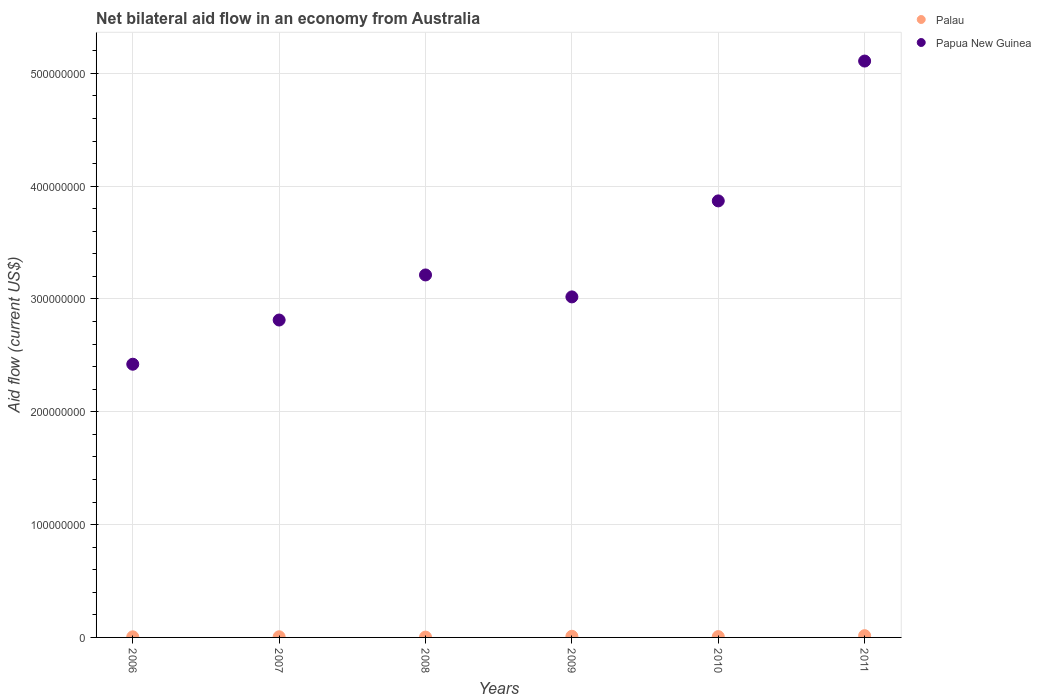What is the net bilateral aid flow in Palau in 2010?
Make the answer very short. 7.40e+05. Across all years, what is the maximum net bilateral aid flow in Palau?
Your answer should be compact. 1.57e+06. Across all years, what is the minimum net bilateral aid flow in Papua New Guinea?
Your response must be concise. 2.42e+08. In which year was the net bilateral aid flow in Palau maximum?
Keep it short and to the point. 2011. What is the total net bilateral aid flow in Palau in the graph?
Provide a succinct answer. 4.71e+06. What is the difference between the net bilateral aid flow in Papua New Guinea in 2007 and that in 2011?
Your answer should be compact. -2.30e+08. What is the difference between the net bilateral aid flow in Palau in 2011 and the net bilateral aid flow in Papua New Guinea in 2010?
Provide a succinct answer. -3.85e+08. What is the average net bilateral aid flow in Papua New Guinea per year?
Your answer should be very brief. 3.41e+08. In the year 2010, what is the difference between the net bilateral aid flow in Papua New Guinea and net bilateral aid flow in Palau?
Offer a terse response. 3.86e+08. In how many years, is the net bilateral aid flow in Palau greater than 260000000 US$?
Make the answer very short. 0. What is the ratio of the net bilateral aid flow in Papua New Guinea in 2007 to that in 2009?
Offer a very short reply. 0.93. What is the difference between the highest and the second highest net bilateral aid flow in Palau?
Offer a very short reply. 5.60e+05. What is the difference between the highest and the lowest net bilateral aid flow in Palau?
Give a very brief answer. 1.28e+06. In how many years, is the net bilateral aid flow in Papua New Guinea greater than the average net bilateral aid flow in Papua New Guinea taken over all years?
Offer a very short reply. 2. Does the net bilateral aid flow in Palau monotonically increase over the years?
Give a very brief answer. No. Is the net bilateral aid flow in Papua New Guinea strictly less than the net bilateral aid flow in Palau over the years?
Provide a short and direct response. No. What is the difference between two consecutive major ticks on the Y-axis?
Ensure brevity in your answer.  1.00e+08. How many legend labels are there?
Make the answer very short. 2. How are the legend labels stacked?
Provide a short and direct response. Vertical. What is the title of the graph?
Your answer should be compact. Net bilateral aid flow in an economy from Australia. Does "Low & middle income" appear as one of the legend labels in the graph?
Provide a succinct answer. No. What is the Aid flow (current US$) of Palau in 2006?
Make the answer very short. 5.20e+05. What is the Aid flow (current US$) of Papua New Guinea in 2006?
Provide a succinct answer. 2.42e+08. What is the Aid flow (current US$) in Palau in 2007?
Your answer should be compact. 5.80e+05. What is the Aid flow (current US$) in Papua New Guinea in 2007?
Provide a succinct answer. 2.81e+08. What is the Aid flow (current US$) in Palau in 2008?
Offer a very short reply. 2.90e+05. What is the Aid flow (current US$) of Papua New Guinea in 2008?
Ensure brevity in your answer.  3.21e+08. What is the Aid flow (current US$) in Palau in 2009?
Keep it short and to the point. 1.01e+06. What is the Aid flow (current US$) of Papua New Guinea in 2009?
Offer a terse response. 3.02e+08. What is the Aid flow (current US$) in Palau in 2010?
Ensure brevity in your answer.  7.40e+05. What is the Aid flow (current US$) in Papua New Guinea in 2010?
Provide a short and direct response. 3.87e+08. What is the Aid flow (current US$) of Palau in 2011?
Your answer should be compact. 1.57e+06. What is the Aid flow (current US$) in Papua New Guinea in 2011?
Make the answer very short. 5.11e+08. Across all years, what is the maximum Aid flow (current US$) of Palau?
Offer a very short reply. 1.57e+06. Across all years, what is the maximum Aid flow (current US$) of Papua New Guinea?
Give a very brief answer. 5.11e+08. Across all years, what is the minimum Aid flow (current US$) of Papua New Guinea?
Your answer should be compact. 2.42e+08. What is the total Aid flow (current US$) of Palau in the graph?
Your answer should be very brief. 4.71e+06. What is the total Aid flow (current US$) of Papua New Guinea in the graph?
Provide a short and direct response. 2.04e+09. What is the difference between the Aid flow (current US$) in Palau in 2006 and that in 2007?
Keep it short and to the point. -6.00e+04. What is the difference between the Aid flow (current US$) of Papua New Guinea in 2006 and that in 2007?
Offer a terse response. -3.92e+07. What is the difference between the Aid flow (current US$) in Palau in 2006 and that in 2008?
Your answer should be very brief. 2.30e+05. What is the difference between the Aid flow (current US$) in Papua New Guinea in 2006 and that in 2008?
Offer a terse response. -7.91e+07. What is the difference between the Aid flow (current US$) in Palau in 2006 and that in 2009?
Ensure brevity in your answer.  -4.90e+05. What is the difference between the Aid flow (current US$) of Papua New Guinea in 2006 and that in 2009?
Provide a succinct answer. -5.97e+07. What is the difference between the Aid flow (current US$) in Papua New Guinea in 2006 and that in 2010?
Provide a succinct answer. -1.45e+08. What is the difference between the Aid flow (current US$) in Palau in 2006 and that in 2011?
Keep it short and to the point. -1.05e+06. What is the difference between the Aid flow (current US$) of Papua New Guinea in 2006 and that in 2011?
Ensure brevity in your answer.  -2.69e+08. What is the difference between the Aid flow (current US$) of Papua New Guinea in 2007 and that in 2008?
Keep it short and to the point. -4.00e+07. What is the difference between the Aid flow (current US$) in Palau in 2007 and that in 2009?
Make the answer very short. -4.30e+05. What is the difference between the Aid flow (current US$) of Papua New Guinea in 2007 and that in 2009?
Provide a short and direct response. -2.05e+07. What is the difference between the Aid flow (current US$) in Papua New Guinea in 2007 and that in 2010?
Your response must be concise. -1.06e+08. What is the difference between the Aid flow (current US$) in Palau in 2007 and that in 2011?
Your answer should be very brief. -9.90e+05. What is the difference between the Aid flow (current US$) in Papua New Guinea in 2007 and that in 2011?
Provide a short and direct response. -2.30e+08. What is the difference between the Aid flow (current US$) of Palau in 2008 and that in 2009?
Offer a very short reply. -7.20e+05. What is the difference between the Aid flow (current US$) of Papua New Guinea in 2008 and that in 2009?
Provide a short and direct response. 1.94e+07. What is the difference between the Aid flow (current US$) in Palau in 2008 and that in 2010?
Provide a short and direct response. -4.50e+05. What is the difference between the Aid flow (current US$) in Papua New Guinea in 2008 and that in 2010?
Provide a succinct answer. -6.56e+07. What is the difference between the Aid flow (current US$) of Palau in 2008 and that in 2011?
Offer a very short reply. -1.28e+06. What is the difference between the Aid flow (current US$) of Papua New Guinea in 2008 and that in 2011?
Keep it short and to the point. -1.90e+08. What is the difference between the Aid flow (current US$) in Palau in 2009 and that in 2010?
Ensure brevity in your answer.  2.70e+05. What is the difference between the Aid flow (current US$) of Papua New Guinea in 2009 and that in 2010?
Give a very brief answer. -8.51e+07. What is the difference between the Aid flow (current US$) of Palau in 2009 and that in 2011?
Offer a very short reply. -5.60e+05. What is the difference between the Aid flow (current US$) in Papua New Guinea in 2009 and that in 2011?
Your answer should be very brief. -2.09e+08. What is the difference between the Aid flow (current US$) in Palau in 2010 and that in 2011?
Ensure brevity in your answer.  -8.30e+05. What is the difference between the Aid flow (current US$) in Papua New Guinea in 2010 and that in 2011?
Provide a short and direct response. -1.24e+08. What is the difference between the Aid flow (current US$) in Palau in 2006 and the Aid flow (current US$) in Papua New Guinea in 2007?
Your answer should be very brief. -2.81e+08. What is the difference between the Aid flow (current US$) of Palau in 2006 and the Aid flow (current US$) of Papua New Guinea in 2008?
Give a very brief answer. -3.21e+08. What is the difference between the Aid flow (current US$) in Palau in 2006 and the Aid flow (current US$) in Papua New Guinea in 2009?
Offer a terse response. -3.01e+08. What is the difference between the Aid flow (current US$) of Palau in 2006 and the Aid flow (current US$) of Papua New Guinea in 2010?
Your answer should be very brief. -3.86e+08. What is the difference between the Aid flow (current US$) of Palau in 2006 and the Aid flow (current US$) of Papua New Guinea in 2011?
Give a very brief answer. -5.10e+08. What is the difference between the Aid flow (current US$) in Palau in 2007 and the Aid flow (current US$) in Papua New Guinea in 2008?
Keep it short and to the point. -3.21e+08. What is the difference between the Aid flow (current US$) of Palau in 2007 and the Aid flow (current US$) of Papua New Guinea in 2009?
Provide a short and direct response. -3.01e+08. What is the difference between the Aid flow (current US$) of Palau in 2007 and the Aid flow (current US$) of Papua New Guinea in 2010?
Make the answer very short. -3.86e+08. What is the difference between the Aid flow (current US$) of Palau in 2007 and the Aid flow (current US$) of Papua New Guinea in 2011?
Provide a succinct answer. -5.10e+08. What is the difference between the Aid flow (current US$) in Palau in 2008 and the Aid flow (current US$) in Papua New Guinea in 2009?
Your answer should be very brief. -3.02e+08. What is the difference between the Aid flow (current US$) of Palau in 2008 and the Aid flow (current US$) of Papua New Guinea in 2010?
Provide a succinct answer. -3.87e+08. What is the difference between the Aid flow (current US$) in Palau in 2008 and the Aid flow (current US$) in Papua New Guinea in 2011?
Your answer should be very brief. -5.11e+08. What is the difference between the Aid flow (current US$) of Palau in 2009 and the Aid flow (current US$) of Papua New Guinea in 2010?
Your answer should be compact. -3.86e+08. What is the difference between the Aid flow (current US$) in Palau in 2009 and the Aid flow (current US$) in Papua New Guinea in 2011?
Give a very brief answer. -5.10e+08. What is the difference between the Aid flow (current US$) of Palau in 2010 and the Aid flow (current US$) of Papua New Guinea in 2011?
Your response must be concise. -5.10e+08. What is the average Aid flow (current US$) of Palau per year?
Offer a very short reply. 7.85e+05. What is the average Aid flow (current US$) of Papua New Guinea per year?
Your answer should be compact. 3.41e+08. In the year 2006, what is the difference between the Aid flow (current US$) in Palau and Aid flow (current US$) in Papua New Guinea?
Make the answer very short. -2.42e+08. In the year 2007, what is the difference between the Aid flow (current US$) in Palau and Aid flow (current US$) in Papua New Guinea?
Provide a succinct answer. -2.81e+08. In the year 2008, what is the difference between the Aid flow (current US$) in Palau and Aid flow (current US$) in Papua New Guinea?
Provide a short and direct response. -3.21e+08. In the year 2009, what is the difference between the Aid flow (current US$) of Palau and Aid flow (current US$) of Papua New Guinea?
Provide a succinct answer. -3.01e+08. In the year 2010, what is the difference between the Aid flow (current US$) in Palau and Aid flow (current US$) in Papua New Guinea?
Offer a terse response. -3.86e+08. In the year 2011, what is the difference between the Aid flow (current US$) of Palau and Aid flow (current US$) of Papua New Guinea?
Your answer should be compact. -5.09e+08. What is the ratio of the Aid flow (current US$) of Palau in 2006 to that in 2007?
Provide a succinct answer. 0.9. What is the ratio of the Aid flow (current US$) in Papua New Guinea in 2006 to that in 2007?
Keep it short and to the point. 0.86. What is the ratio of the Aid flow (current US$) of Palau in 2006 to that in 2008?
Make the answer very short. 1.79. What is the ratio of the Aid flow (current US$) of Papua New Guinea in 2006 to that in 2008?
Provide a short and direct response. 0.75. What is the ratio of the Aid flow (current US$) in Palau in 2006 to that in 2009?
Make the answer very short. 0.51. What is the ratio of the Aid flow (current US$) in Papua New Guinea in 2006 to that in 2009?
Offer a terse response. 0.8. What is the ratio of the Aid flow (current US$) of Palau in 2006 to that in 2010?
Make the answer very short. 0.7. What is the ratio of the Aid flow (current US$) in Papua New Guinea in 2006 to that in 2010?
Provide a short and direct response. 0.63. What is the ratio of the Aid flow (current US$) of Palau in 2006 to that in 2011?
Offer a very short reply. 0.33. What is the ratio of the Aid flow (current US$) of Papua New Guinea in 2006 to that in 2011?
Offer a very short reply. 0.47. What is the ratio of the Aid flow (current US$) in Palau in 2007 to that in 2008?
Keep it short and to the point. 2. What is the ratio of the Aid flow (current US$) of Papua New Guinea in 2007 to that in 2008?
Offer a very short reply. 0.88. What is the ratio of the Aid flow (current US$) in Palau in 2007 to that in 2009?
Your answer should be compact. 0.57. What is the ratio of the Aid flow (current US$) in Papua New Guinea in 2007 to that in 2009?
Give a very brief answer. 0.93. What is the ratio of the Aid flow (current US$) of Palau in 2007 to that in 2010?
Offer a terse response. 0.78. What is the ratio of the Aid flow (current US$) of Papua New Guinea in 2007 to that in 2010?
Provide a succinct answer. 0.73. What is the ratio of the Aid flow (current US$) of Palau in 2007 to that in 2011?
Provide a succinct answer. 0.37. What is the ratio of the Aid flow (current US$) of Papua New Guinea in 2007 to that in 2011?
Keep it short and to the point. 0.55. What is the ratio of the Aid flow (current US$) of Palau in 2008 to that in 2009?
Keep it short and to the point. 0.29. What is the ratio of the Aid flow (current US$) in Papua New Guinea in 2008 to that in 2009?
Offer a very short reply. 1.06. What is the ratio of the Aid flow (current US$) of Palau in 2008 to that in 2010?
Provide a succinct answer. 0.39. What is the ratio of the Aid flow (current US$) in Papua New Guinea in 2008 to that in 2010?
Provide a short and direct response. 0.83. What is the ratio of the Aid flow (current US$) of Palau in 2008 to that in 2011?
Your answer should be very brief. 0.18. What is the ratio of the Aid flow (current US$) of Papua New Guinea in 2008 to that in 2011?
Give a very brief answer. 0.63. What is the ratio of the Aid flow (current US$) in Palau in 2009 to that in 2010?
Your answer should be very brief. 1.36. What is the ratio of the Aid flow (current US$) of Papua New Guinea in 2009 to that in 2010?
Your answer should be very brief. 0.78. What is the ratio of the Aid flow (current US$) in Palau in 2009 to that in 2011?
Your answer should be compact. 0.64. What is the ratio of the Aid flow (current US$) of Papua New Guinea in 2009 to that in 2011?
Make the answer very short. 0.59. What is the ratio of the Aid flow (current US$) of Palau in 2010 to that in 2011?
Offer a terse response. 0.47. What is the ratio of the Aid flow (current US$) in Papua New Guinea in 2010 to that in 2011?
Give a very brief answer. 0.76. What is the difference between the highest and the second highest Aid flow (current US$) of Palau?
Ensure brevity in your answer.  5.60e+05. What is the difference between the highest and the second highest Aid flow (current US$) in Papua New Guinea?
Offer a very short reply. 1.24e+08. What is the difference between the highest and the lowest Aid flow (current US$) of Palau?
Make the answer very short. 1.28e+06. What is the difference between the highest and the lowest Aid flow (current US$) in Papua New Guinea?
Your answer should be compact. 2.69e+08. 